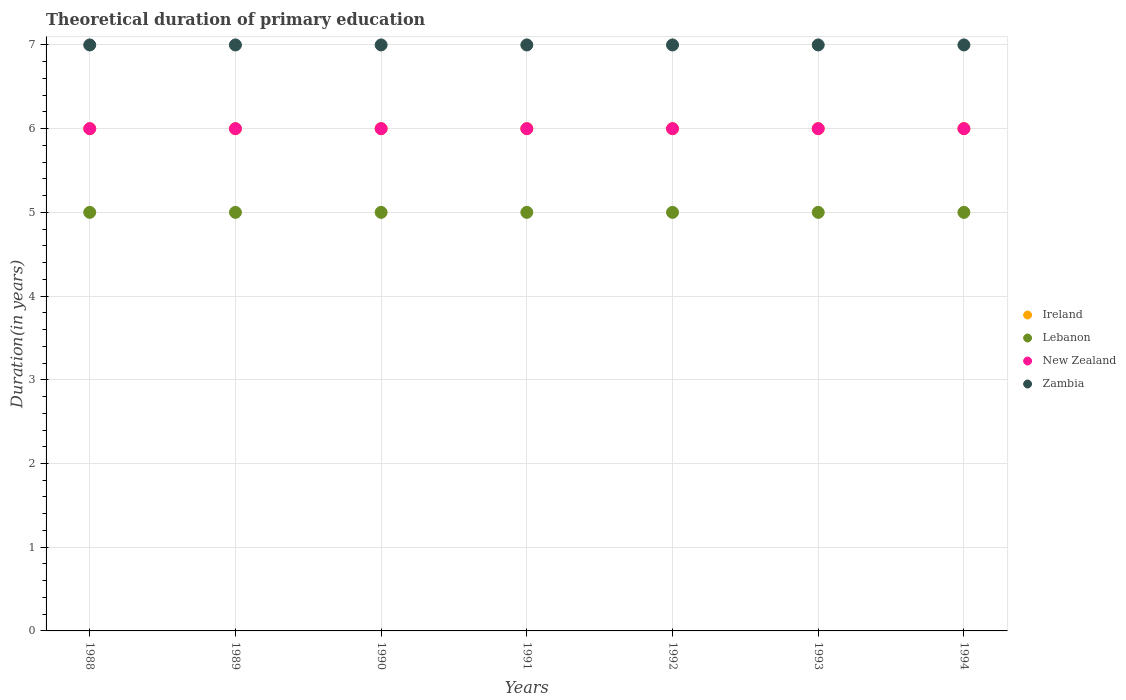How many different coloured dotlines are there?
Your answer should be compact. 4. What is the total theoretical duration of primary education in Zambia in 1988?
Provide a short and direct response. 7. Across all years, what is the minimum total theoretical duration of primary education in Ireland?
Provide a short and direct response. 6. In which year was the total theoretical duration of primary education in Ireland minimum?
Your response must be concise. 1988. What is the total total theoretical duration of primary education in New Zealand in the graph?
Provide a short and direct response. 42. What is the difference between the total theoretical duration of primary education in Ireland in 1992 and the total theoretical duration of primary education in Lebanon in 1989?
Your response must be concise. 1. What is the average total theoretical duration of primary education in Ireland per year?
Your answer should be very brief. 6. In the year 1989, what is the difference between the total theoretical duration of primary education in Zambia and total theoretical duration of primary education in Lebanon?
Your answer should be compact. 2. Is the sum of the total theoretical duration of primary education in Lebanon in 1990 and 1993 greater than the maximum total theoretical duration of primary education in Zambia across all years?
Provide a short and direct response. Yes. Is it the case that in every year, the sum of the total theoretical duration of primary education in New Zealand and total theoretical duration of primary education in Zambia  is greater than the sum of total theoretical duration of primary education in Ireland and total theoretical duration of primary education in Lebanon?
Offer a terse response. Yes. Is it the case that in every year, the sum of the total theoretical duration of primary education in New Zealand and total theoretical duration of primary education in Zambia  is greater than the total theoretical duration of primary education in Ireland?
Give a very brief answer. Yes. Does the total theoretical duration of primary education in Zambia monotonically increase over the years?
Your answer should be compact. No. Is the total theoretical duration of primary education in Ireland strictly greater than the total theoretical duration of primary education in New Zealand over the years?
Ensure brevity in your answer.  No. Is the total theoretical duration of primary education in New Zealand strictly less than the total theoretical duration of primary education in Lebanon over the years?
Your answer should be compact. No. How many dotlines are there?
Offer a very short reply. 4. How many years are there in the graph?
Ensure brevity in your answer.  7. What is the difference between two consecutive major ticks on the Y-axis?
Your answer should be compact. 1. Does the graph contain any zero values?
Offer a very short reply. No. Does the graph contain grids?
Ensure brevity in your answer.  Yes. Where does the legend appear in the graph?
Ensure brevity in your answer.  Center right. How are the legend labels stacked?
Your response must be concise. Vertical. What is the title of the graph?
Provide a succinct answer. Theoretical duration of primary education. Does "Angola" appear as one of the legend labels in the graph?
Offer a terse response. No. What is the label or title of the Y-axis?
Keep it short and to the point. Duration(in years). What is the Duration(in years) in Lebanon in 1988?
Provide a short and direct response. 5. What is the Duration(in years) of New Zealand in 1988?
Offer a very short reply. 6. What is the Duration(in years) of Zambia in 1988?
Make the answer very short. 7. What is the Duration(in years) in New Zealand in 1989?
Offer a very short reply. 6. What is the Duration(in years) of Zambia in 1989?
Offer a very short reply. 7. What is the Duration(in years) of Ireland in 1990?
Your answer should be very brief. 6. What is the Duration(in years) of Lebanon in 1990?
Keep it short and to the point. 5. What is the Duration(in years) in Lebanon in 1992?
Your answer should be very brief. 5. What is the Duration(in years) in New Zealand in 1992?
Give a very brief answer. 6. What is the Duration(in years) in Ireland in 1993?
Your response must be concise. 6. What is the Duration(in years) of Lebanon in 1993?
Your answer should be very brief. 5. What is the Duration(in years) in New Zealand in 1994?
Keep it short and to the point. 6. What is the Duration(in years) of Zambia in 1994?
Provide a succinct answer. 7. Across all years, what is the maximum Duration(in years) of Ireland?
Offer a very short reply. 6. Across all years, what is the maximum Duration(in years) of Lebanon?
Ensure brevity in your answer.  5. Across all years, what is the maximum Duration(in years) of Zambia?
Ensure brevity in your answer.  7. Across all years, what is the minimum Duration(in years) of Ireland?
Keep it short and to the point. 6. Across all years, what is the minimum Duration(in years) of Lebanon?
Provide a succinct answer. 5. Across all years, what is the minimum Duration(in years) of New Zealand?
Give a very brief answer. 6. What is the total Duration(in years) of Ireland in the graph?
Keep it short and to the point. 42. What is the total Duration(in years) in New Zealand in the graph?
Ensure brevity in your answer.  42. What is the total Duration(in years) of Zambia in the graph?
Make the answer very short. 49. What is the difference between the Duration(in years) of Ireland in 1988 and that in 1989?
Your answer should be compact. 0. What is the difference between the Duration(in years) of New Zealand in 1988 and that in 1989?
Provide a short and direct response. 0. What is the difference between the Duration(in years) of Zambia in 1988 and that in 1989?
Offer a terse response. 0. What is the difference between the Duration(in years) of Ireland in 1988 and that in 1990?
Offer a very short reply. 0. What is the difference between the Duration(in years) in New Zealand in 1988 and that in 1990?
Your response must be concise. 0. What is the difference between the Duration(in years) of Ireland in 1988 and that in 1991?
Keep it short and to the point. 0. What is the difference between the Duration(in years) in New Zealand in 1988 and that in 1991?
Give a very brief answer. 0. What is the difference between the Duration(in years) in Lebanon in 1988 and that in 1992?
Provide a succinct answer. 0. What is the difference between the Duration(in years) in Zambia in 1988 and that in 1992?
Ensure brevity in your answer.  0. What is the difference between the Duration(in years) in Ireland in 1988 and that in 1993?
Make the answer very short. 0. What is the difference between the Duration(in years) in Lebanon in 1988 and that in 1994?
Ensure brevity in your answer.  0. What is the difference between the Duration(in years) in Zambia in 1988 and that in 1994?
Offer a very short reply. 0. What is the difference between the Duration(in years) in Ireland in 1989 and that in 1990?
Give a very brief answer. 0. What is the difference between the Duration(in years) in Lebanon in 1989 and that in 1990?
Give a very brief answer. 0. What is the difference between the Duration(in years) in New Zealand in 1989 and that in 1990?
Give a very brief answer. 0. What is the difference between the Duration(in years) in Zambia in 1989 and that in 1990?
Ensure brevity in your answer.  0. What is the difference between the Duration(in years) of Zambia in 1989 and that in 1991?
Give a very brief answer. 0. What is the difference between the Duration(in years) in Ireland in 1989 and that in 1992?
Give a very brief answer. 0. What is the difference between the Duration(in years) in New Zealand in 1989 and that in 1992?
Keep it short and to the point. 0. What is the difference between the Duration(in years) of Zambia in 1989 and that in 1993?
Your answer should be compact. 0. What is the difference between the Duration(in years) of Ireland in 1989 and that in 1994?
Your answer should be very brief. 0. What is the difference between the Duration(in years) of Lebanon in 1989 and that in 1994?
Offer a terse response. 0. What is the difference between the Duration(in years) in New Zealand in 1989 and that in 1994?
Offer a terse response. 0. What is the difference between the Duration(in years) in Ireland in 1990 and that in 1992?
Your response must be concise. 0. What is the difference between the Duration(in years) of Zambia in 1990 and that in 1992?
Ensure brevity in your answer.  0. What is the difference between the Duration(in years) in New Zealand in 1990 and that in 1993?
Give a very brief answer. 0. What is the difference between the Duration(in years) in Zambia in 1990 and that in 1993?
Provide a short and direct response. 0. What is the difference between the Duration(in years) in Ireland in 1990 and that in 1994?
Provide a succinct answer. 0. What is the difference between the Duration(in years) of Zambia in 1990 and that in 1994?
Your answer should be very brief. 0. What is the difference between the Duration(in years) of Zambia in 1991 and that in 1992?
Provide a succinct answer. 0. What is the difference between the Duration(in years) in Ireland in 1991 and that in 1993?
Your response must be concise. 0. What is the difference between the Duration(in years) in New Zealand in 1991 and that in 1993?
Provide a succinct answer. 0. What is the difference between the Duration(in years) of Zambia in 1991 and that in 1993?
Provide a short and direct response. 0. What is the difference between the Duration(in years) in Lebanon in 1992 and that in 1993?
Provide a short and direct response. 0. What is the difference between the Duration(in years) of New Zealand in 1992 and that in 1993?
Your response must be concise. 0. What is the difference between the Duration(in years) in Ireland in 1992 and that in 1994?
Make the answer very short. 0. What is the difference between the Duration(in years) in Zambia in 1992 and that in 1994?
Your answer should be very brief. 0. What is the difference between the Duration(in years) of Lebanon in 1993 and that in 1994?
Your answer should be very brief. 0. What is the difference between the Duration(in years) in Zambia in 1993 and that in 1994?
Offer a terse response. 0. What is the difference between the Duration(in years) in Ireland in 1988 and the Duration(in years) in New Zealand in 1989?
Give a very brief answer. 0. What is the difference between the Duration(in years) in Ireland in 1988 and the Duration(in years) in Zambia in 1989?
Your response must be concise. -1. What is the difference between the Duration(in years) in Lebanon in 1988 and the Duration(in years) in New Zealand in 1989?
Offer a terse response. -1. What is the difference between the Duration(in years) of Lebanon in 1988 and the Duration(in years) of Zambia in 1989?
Your answer should be very brief. -2. What is the difference between the Duration(in years) in New Zealand in 1988 and the Duration(in years) in Zambia in 1989?
Give a very brief answer. -1. What is the difference between the Duration(in years) in Ireland in 1988 and the Duration(in years) in Lebanon in 1990?
Make the answer very short. 1. What is the difference between the Duration(in years) in Ireland in 1988 and the Duration(in years) in Lebanon in 1991?
Offer a very short reply. 1. What is the difference between the Duration(in years) in Ireland in 1988 and the Duration(in years) in New Zealand in 1991?
Your answer should be compact. 0. What is the difference between the Duration(in years) in Lebanon in 1988 and the Duration(in years) in New Zealand in 1991?
Provide a succinct answer. -1. What is the difference between the Duration(in years) in Ireland in 1988 and the Duration(in years) in New Zealand in 1992?
Your response must be concise. 0. What is the difference between the Duration(in years) of Lebanon in 1988 and the Duration(in years) of Zambia in 1992?
Offer a very short reply. -2. What is the difference between the Duration(in years) in New Zealand in 1988 and the Duration(in years) in Zambia in 1992?
Provide a short and direct response. -1. What is the difference between the Duration(in years) in Ireland in 1988 and the Duration(in years) in Lebanon in 1993?
Your response must be concise. 1. What is the difference between the Duration(in years) of Lebanon in 1988 and the Duration(in years) of New Zealand in 1993?
Your answer should be very brief. -1. What is the difference between the Duration(in years) in Ireland in 1988 and the Duration(in years) in Lebanon in 1994?
Make the answer very short. 1. What is the difference between the Duration(in years) of Ireland in 1988 and the Duration(in years) of Zambia in 1994?
Your response must be concise. -1. What is the difference between the Duration(in years) in Lebanon in 1988 and the Duration(in years) in New Zealand in 1994?
Give a very brief answer. -1. What is the difference between the Duration(in years) in Ireland in 1989 and the Duration(in years) in Zambia in 1990?
Your answer should be compact. -1. What is the difference between the Duration(in years) in Lebanon in 1989 and the Duration(in years) in New Zealand in 1990?
Your response must be concise. -1. What is the difference between the Duration(in years) in Lebanon in 1989 and the Duration(in years) in Zambia in 1990?
Ensure brevity in your answer.  -2. What is the difference between the Duration(in years) of New Zealand in 1989 and the Duration(in years) of Zambia in 1990?
Make the answer very short. -1. What is the difference between the Duration(in years) in Ireland in 1989 and the Duration(in years) in New Zealand in 1991?
Ensure brevity in your answer.  0. What is the difference between the Duration(in years) in Lebanon in 1989 and the Duration(in years) in New Zealand in 1991?
Keep it short and to the point. -1. What is the difference between the Duration(in years) in New Zealand in 1989 and the Duration(in years) in Zambia in 1991?
Offer a very short reply. -1. What is the difference between the Duration(in years) in Ireland in 1989 and the Duration(in years) in Zambia in 1992?
Your response must be concise. -1. What is the difference between the Duration(in years) in Lebanon in 1989 and the Duration(in years) in Zambia in 1992?
Make the answer very short. -2. What is the difference between the Duration(in years) in Ireland in 1989 and the Duration(in years) in Lebanon in 1993?
Offer a very short reply. 1. What is the difference between the Duration(in years) of Ireland in 1989 and the Duration(in years) of New Zealand in 1993?
Offer a very short reply. 0. What is the difference between the Duration(in years) of Ireland in 1989 and the Duration(in years) of Zambia in 1993?
Keep it short and to the point. -1. What is the difference between the Duration(in years) of Lebanon in 1989 and the Duration(in years) of Zambia in 1993?
Give a very brief answer. -2. What is the difference between the Duration(in years) in New Zealand in 1989 and the Duration(in years) in Zambia in 1993?
Offer a very short reply. -1. What is the difference between the Duration(in years) in Ireland in 1989 and the Duration(in years) in Lebanon in 1994?
Make the answer very short. 1. What is the difference between the Duration(in years) of Ireland in 1990 and the Duration(in years) of New Zealand in 1991?
Keep it short and to the point. 0. What is the difference between the Duration(in years) of Lebanon in 1990 and the Duration(in years) of New Zealand in 1991?
Your response must be concise. -1. What is the difference between the Duration(in years) in Ireland in 1990 and the Duration(in years) in New Zealand in 1992?
Provide a short and direct response. 0. What is the difference between the Duration(in years) in Lebanon in 1990 and the Duration(in years) in New Zealand in 1992?
Give a very brief answer. -1. What is the difference between the Duration(in years) of Lebanon in 1990 and the Duration(in years) of Zambia in 1992?
Provide a succinct answer. -2. What is the difference between the Duration(in years) of New Zealand in 1990 and the Duration(in years) of Zambia in 1992?
Your response must be concise. -1. What is the difference between the Duration(in years) in Ireland in 1990 and the Duration(in years) in Zambia in 1993?
Your answer should be very brief. -1. What is the difference between the Duration(in years) of Lebanon in 1990 and the Duration(in years) of New Zealand in 1993?
Offer a terse response. -1. What is the difference between the Duration(in years) in Lebanon in 1990 and the Duration(in years) in Zambia in 1993?
Your response must be concise. -2. What is the difference between the Duration(in years) of Ireland in 1990 and the Duration(in years) of Lebanon in 1994?
Provide a short and direct response. 1. What is the difference between the Duration(in years) in Ireland in 1990 and the Duration(in years) in New Zealand in 1994?
Provide a succinct answer. 0. What is the difference between the Duration(in years) in Ireland in 1990 and the Duration(in years) in Zambia in 1994?
Your answer should be compact. -1. What is the difference between the Duration(in years) of Lebanon in 1990 and the Duration(in years) of New Zealand in 1994?
Keep it short and to the point. -1. What is the difference between the Duration(in years) in Ireland in 1991 and the Duration(in years) in Lebanon in 1992?
Provide a succinct answer. 1. What is the difference between the Duration(in years) in Ireland in 1991 and the Duration(in years) in Zambia in 1992?
Offer a very short reply. -1. What is the difference between the Duration(in years) in Ireland in 1991 and the Duration(in years) in Lebanon in 1993?
Make the answer very short. 1. What is the difference between the Duration(in years) in Ireland in 1991 and the Duration(in years) in Zambia in 1993?
Give a very brief answer. -1. What is the difference between the Duration(in years) of Lebanon in 1991 and the Duration(in years) of New Zealand in 1993?
Your answer should be very brief. -1. What is the difference between the Duration(in years) in New Zealand in 1991 and the Duration(in years) in Zambia in 1993?
Your response must be concise. -1. What is the difference between the Duration(in years) in Ireland in 1991 and the Duration(in years) in New Zealand in 1994?
Offer a terse response. 0. What is the difference between the Duration(in years) in Ireland in 1991 and the Duration(in years) in Zambia in 1994?
Your answer should be compact. -1. What is the difference between the Duration(in years) in New Zealand in 1991 and the Duration(in years) in Zambia in 1994?
Ensure brevity in your answer.  -1. What is the difference between the Duration(in years) of Ireland in 1992 and the Duration(in years) of Lebanon in 1993?
Your answer should be compact. 1. What is the difference between the Duration(in years) in Ireland in 1992 and the Duration(in years) in New Zealand in 1993?
Offer a terse response. 0. What is the difference between the Duration(in years) in Ireland in 1992 and the Duration(in years) in Zambia in 1993?
Offer a very short reply. -1. What is the difference between the Duration(in years) of Lebanon in 1992 and the Duration(in years) of New Zealand in 1993?
Make the answer very short. -1. What is the difference between the Duration(in years) of Lebanon in 1992 and the Duration(in years) of Zambia in 1993?
Your response must be concise. -2. What is the difference between the Duration(in years) of Ireland in 1992 and the Duration(in years) of Lebanon in 1994?
Your answer should be very brief. 1. What is the difference between the Duration(in years) of Ireland in 1992 and the Duration(in years) of New Zealand in 1994?
Ensure brevity in your answer.  0. What is the difference between the Duration(in years) in Lebanon in 1992 and the Duration(in years) in New Zealand in 1994?
Give a very brief answer. -1. What is the difference between the Duration(in years) in Lebanon in 1992 and the Duration(in years) in Zambia in 1994?
Offer a terse response. -2. What is the difference between the Duration(in years) of Lebanon in 1993 and the Duration(in years) of New Zealand in 1994?
Your answer should be very brief. -1. In the year 1988, what is the difference between the Duration(in years) of Ireland and Duration(in years) of New Zealand?
Keep it short and to the point. 0. In the year 1988, what is the difference between the Duration(in years) of Lebanon and Duration(in years) of Zambia?
Your answer should be very brief. -2. In the year 1988, what is the difference between the Duration(in years) in New Zealand and Duration(in years) in Zambia?
Provide a succinct answer. -1. In the year 1989, what is the difference between the Duration(in years) of Ireland and Duration(in years) of New Zealand?
Offer a very short reply. 0. In the year 1990, what is the difference between the Duration(in years) in Ireland and Duration(in years) in Lebanon?
Keep it short and to the point. 1. In the year 1990, what is the difference between the Duration(in years) in Ireland and Duration(in years) in New Zealand?
Provide a short and direct response. 0. In the year 1990, what is the difference between the Duration(in years) in Lebanon and Duration(in years) in Zambia?
Make the answer very short. -2. In the year 1990, what is the difference between the Duration(in years) in New Zealand and Duration(in years) in Zambia?
Your response must be concise. -1. In the year 1991, what is the difference between the Duration(in years) of Ireland and Duration(in years) of Lebanon?
Provide a short and direct response. 1. In the year 1991, what is the difference between the Duration(in years) of New Zealand and Duration(in years) of Zambia?
Give a very brief answer. -1. In the year 1992, what is the difference between the Duration(in years) of Lebanon and Duration(in years) of New Zealand?
Give a very brief answer. -1. In the year 1992, what is the difference between the Duration(in years) of New Zealand and Duration(in years) of Zambia?
Your response must be concise. -1. In the year 1993, what is the difference between the Duration(in years) of Ireland and Duration(in years) of Lebanon?
Offer a terse response. 1. In the year 1993, what is the difference between the Duration(in years) of Ireland and Duration(in years) of New Zealand?
Offer a terse response. 0. In the year 1993, what is the difference between the Duration(in years) of Ireland and Duration(in years) of Zambia?
Provide a short and direct response. -1. In the year 1993, what is the difference between the Duration(in years) of Lebanon and Duration(in years) of Zambia?
Your answer should be very brief. -2. In the year 1993, what is the difference between the Duration(in years) of New Zealand and Duration(in years) of Zambia?
Give a very brief answer. -1. In the year 1994, what is the difference between the Duration(in years) of Lebanon and Duration(in years) of New Zealand?
Offer a terse response. -1. In the year 1994, what is the difference between the Duration(in years) in Lebanon and Duration(in years) in Zambia?
Ensure brevity in your answer.  -2. What is the ratio of the Duration(in years) of Ireland in 1988 to that in 1989?
Ensure brevity in your answer.  1. What is the ratio of the Duration(in years) of Lebanon in 1988 to that in 1989?
Keep it short and to the point. 1. What is the ratio of the Duration(in years) in New Zealand in 1988 to that in 1989?
Your answer should be compact. 1. What is the ratio of the Duration(in years) in Ireland in 1988 to that in 1990?
Make the answer very short. 1. What is the ratio of the Duration(in years) of Lebanon in 1988 to that in 1990?
Your answer should be compact. 1. What is the ratio of the Duration(in years) in Zambia in 1988 to that in 1990?
Keep it short and to the point. 1. What is the ratio of the Duration(in years) of Ireland in 1988 to that in 1991?
Your answer should be compact. 1. What is the ratio of the Duration(in years) of Lebanon in 1988 to that in 1991?
Your response must be concise. 1. What is the ratio of the Duration(in years) of Ireland in 1988 to that in 1992?
Provide a short and direct response. 1. What is the ratio of the Duration(in years) in Ireland in 1988 to that in 1993?
Your answer should be very brief. 1. What is the ratio of the Duration(in years) in New Zealand in 1988 to that in 1993?
Your response must be concise. 1. What is the ratio of the Duration(in years) in Zambia in 1988 to that in 1993?
Offer a terse response. 1. What is the ratio of the Duration(in years) of Ireland in 1988 to that in 1994?
Your answer should be compact. 1. What is the ratio of the Duration(in years) in Lebanon in 1988 to that in 1994?
Ensure brevity in your answer.  1. What is the ratio of the Duration(in years) in New Zealand in 1988 to that in 1994?
Your answer should be compact. 1. What is the ratio of the Duration(in years) in Zambia in 1988 to that in 1994?
Your answer should be compact. 1. What is the ratio of the Duration(in years) of Ireland in 1989 to that in 1990?
Your answer should be compact. 1. What is the ratio of the Duration(in years) in Lebanon in 1989 to that in 1990?
Make the answer very short. 1. What is the ratio of the Duration(in years) in New Zealand in 1989 to that in 1990?
Your response must be concise. 1. What is the ratio of the Duration(in years) in Ireland in 1989 to that in 1991?
Ensure brevity in your answer.  1. What is the ratio of the Duration(in years) of Lebanon in 1989 to that in 1991?
Offer a very short reply. 1. What is the ratio of the Duration(in years) of Ireland in 1989 to that in 1992?
Provide a short and direct response. 1. What is the ratio of the Duration(in years) of Lebanon in 1989 to that in 1992?
Provide a succinct answer. 1. What is the ratio of the Duration(in years) of New Zealand in 1989 to that in 1992?
Your answer should be very brief. 1. What is the ratio of the Duration(in years) in Ireland in 1989 to that in 1993?
Keep it short and to the point. 1. What is the ratio of the Duration(in years) in Lebanon in 1989 to that in 1993?
Make the answer very short. 1. What is the ratio of the Duration(in years) of Zambia in 1989 to that in 1993?
Keep it short and to the point. 1. What is the ratio of the Duration(in years) of New Zealand in 1989 to that in 1994?
Ensure brevity in your answer.  1. What is the ratio of the Duration(in years) of Zambia in 1989 to that in 1994?
Ensure brevity in your answer.  1. What is the ratio of the Duration(in years) in Lebanon in 1990 to that in 1991?
Offer a very short reply. 1. What is the ratio of the Duration(in years) of Zambia in 1990 to that in 1991?
Offer a very short reply. 1. What is the ratio of the Duration(in years) in New Zealand in 1990 to that in 1992?
Provide a short and direct response. 1. What is the ratio of the Duration(in years) in Zambia in 1990 to that in 1992?
Keep it short and to the point. 1. What is the ratio of the Duration(in years) in Zambia in 1990 to that in 1993?
Provide a succinct answer. 1. What is the ratio of the Duration(in years) of Ireland in 1990 to that in 1994?
Offer a terse response. 1. What is the ratio of the Duration(in years) in New Zealand in 1990 to that in 1994?
Provide a succinct answer. 1. What is the ratio of the Duration(in years) in Zambia in 1990 to that in 1994?
Provide a succinct answer. 1. What is the ratio of the Duration(in years) in Ireland in 1991 to that in 1992?
Ensure brevity in your answer.  1. What is the ratio of the Duration(in years) in New Zealand in 1991 to that in 1992?
Provide a succinct answer. 1. What is the ratio of the Duration(in years) of Ireland in 1991 to that in 1994?
Make the answer very short. 1. What is the ratio of the Duration(in years) of Lebanon in 1991 to that in 1994?
Provide a succinct answer. 1. What is the ratio of the Duration(in years) in New Zealand in 1991 to that in 1994?
Ensure brevity in your answer.  1. What is the ratio of the Duration(in years) of Zambia in 1991 to that in 1994?
Your response must be concise. 1. What is the ratio of the Duration(in years) of Ireland in 1992 to that in 1993?
Provide a succinct answer. 1. What is the ratio of the Duration(in years) in Lebanon in 1992 to that in 1993?
Your answer should be compact. 1. What is the ratio of the Duration(in years) of New Zealand in 1992 to that in 1993?
Your answer should be very brief. 1. What is the ratio of the Duration(in years) in Zambia in 1992 to that in 1993?
Keep it short and to the point. 1. What is the ratio of the Duration(in years) of Lebanon in 1992 to that in 1994?
Ensure brevity in your answer.  1. What is the ratio of the Duration(in years) of New Zealand in 1992 to that in 1994?
Your response must be concise. 1. What is the difference between the highest and the second highest Duration(in years) of Ireland?
Make the answer very short. 0. What is the difference between the highest and the second highest Duration(in years) of Lebanon?
Offer a very short reply. 0. What is the difference between the highest and the second highest Duration(in years) of New Zealand?
Your answer should be compact. 0. What is the difference between the highest and the second highest Duration(in years) of Zambia?
Provide a short and direct response. 0. What is the difference between the highest and the lowest Duration(in years) in Lebanon?
Give a very brief answer. 0. What is the difference between the highest and the lowest Duration(in years) in Zambia?
Offer a very short reply. 0. 